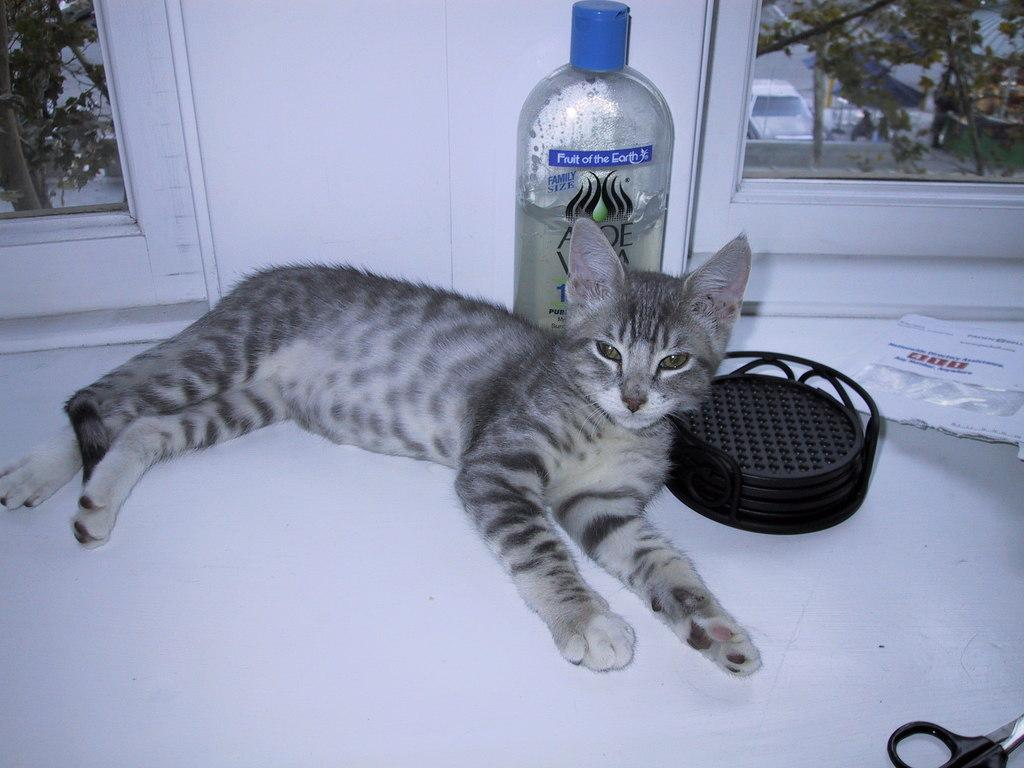What animal can be seen in the image? There is a cat in the image. Where is the cat positioned in relation to the window? The cat is on the corner side of the window. What tools are present in the image? There is a scissor and an oil bottle in the image. What is the main component of the window visible in the image? There is a window glass in the image. What can be seen outside the window? A car is visible through the window. What type of root can be seen growing through the window in the image? There is no root visible in the image; the window glass is clear, and a car can be seen outside. 